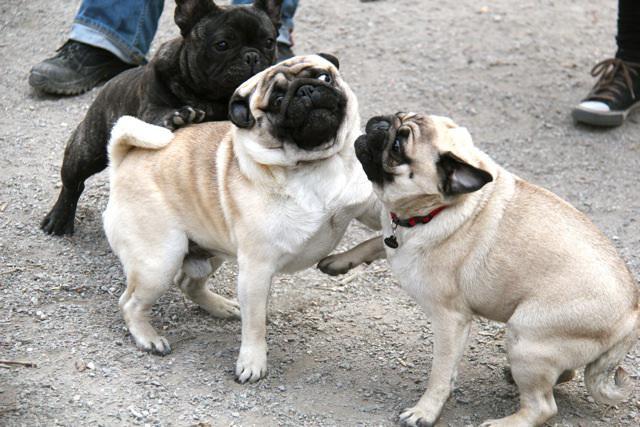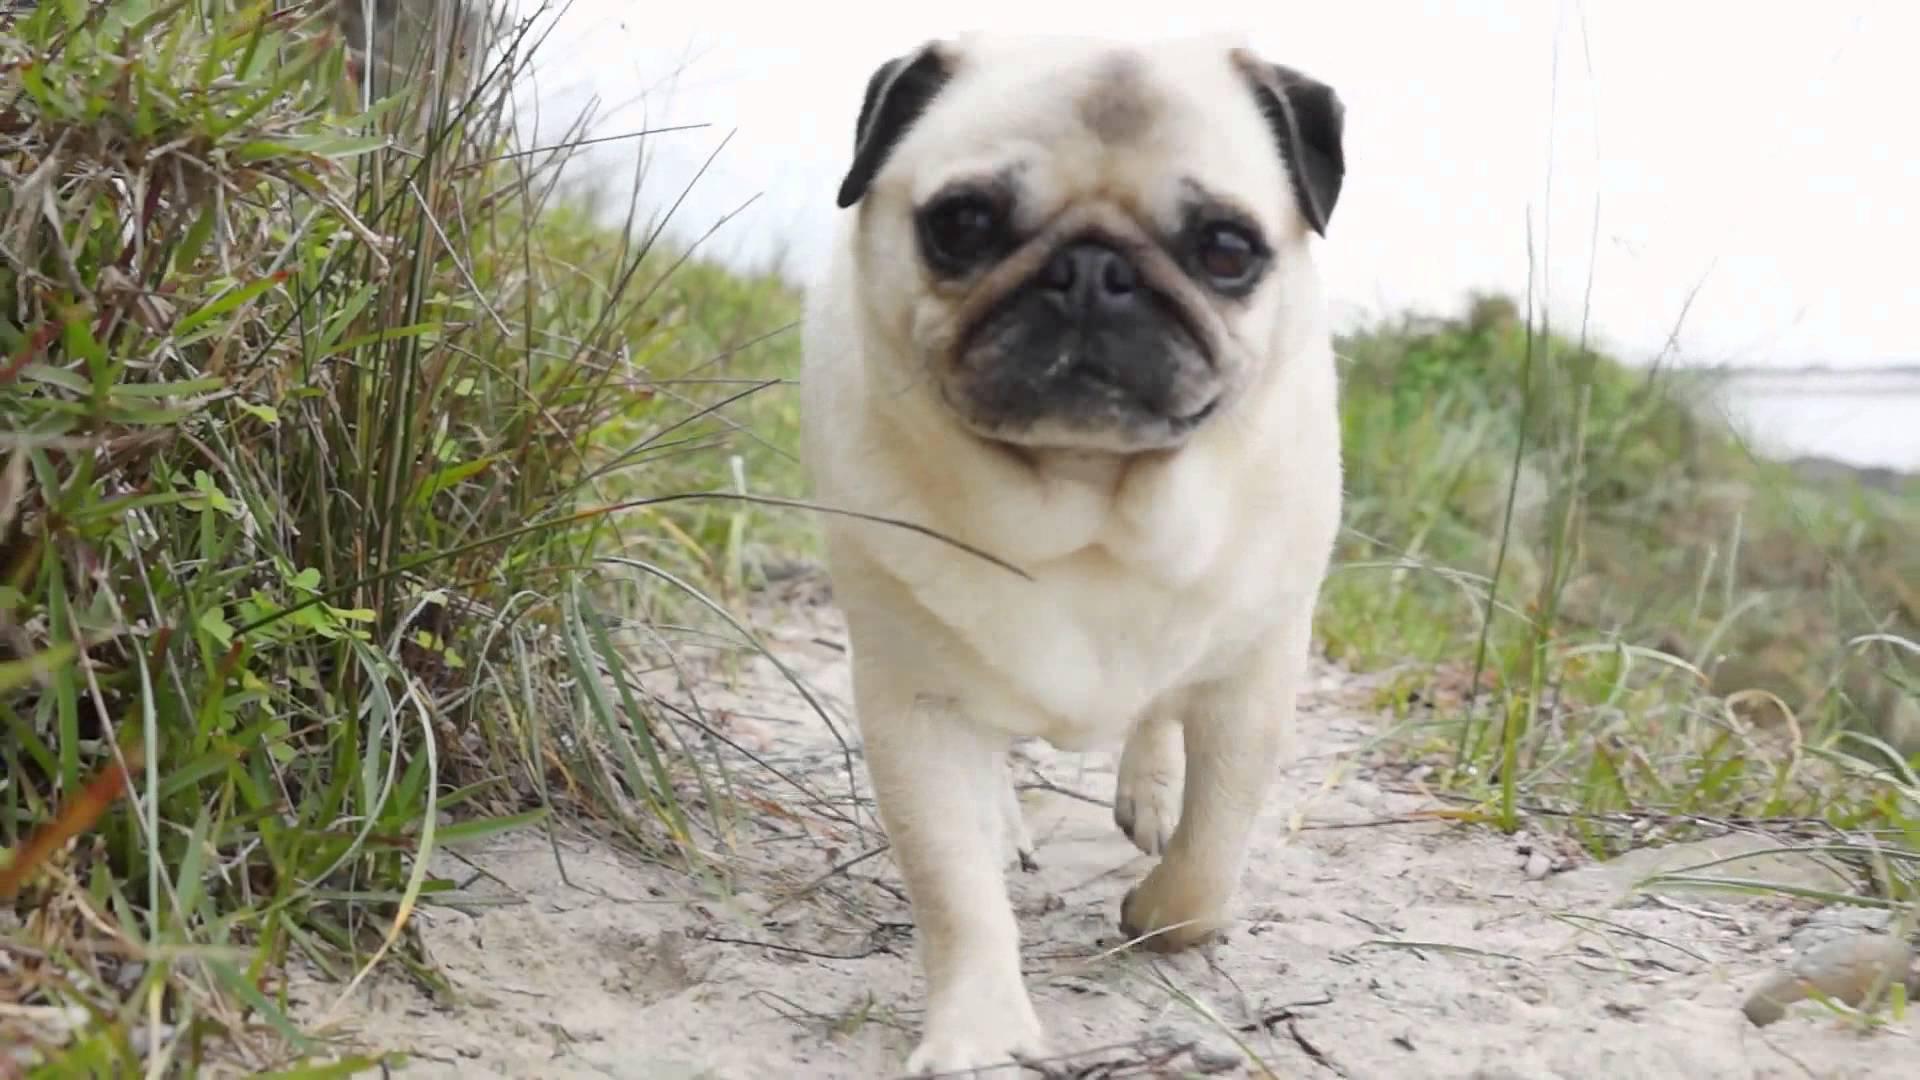The first image is the image on the left, the second image is the image on the right. Evaluate the accuracy of this statement regarding the images: "Four dogs are in sand.". Is it true? Answer yes or no. No. The first image is the image on the left, the second image is the image on the right. Assess this claim about the two images: "An animal wearing clothing is present.". Correct or not? Answer yes or no. No. 